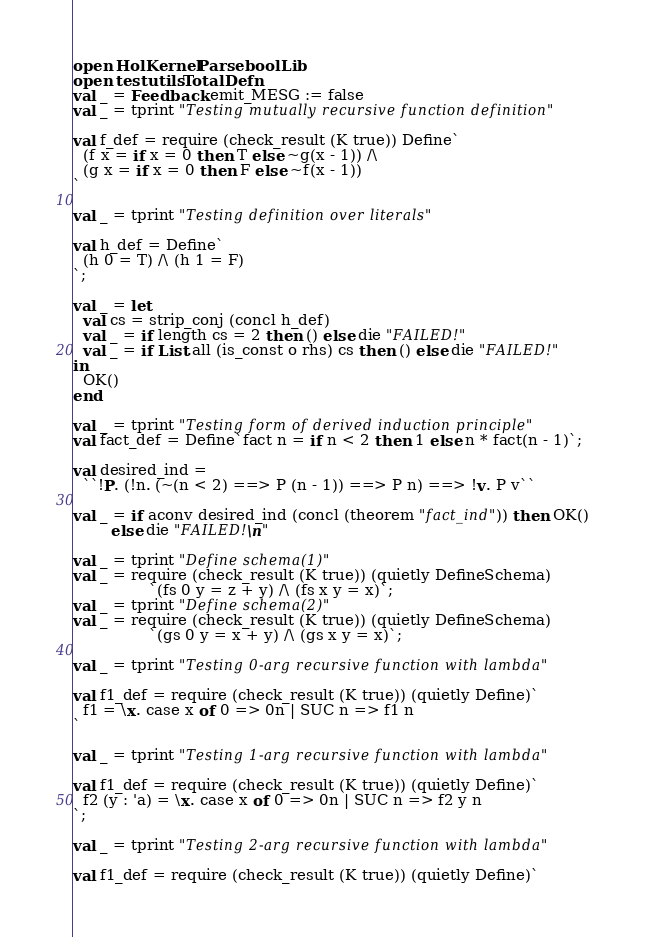Convert code to text. <code><loc_0><loc_0><loc_500><loc_500><_SML_>open HolKernel Parse boolLib
open testutils TotalDefn
val _ = Feedback.emit_MESG := false
val _ = tprint "Testing mutually recursive function definition"

val f_def = require (check_result (K true)) Define`
  (f x = if x = 0 then T else ~g(x - 1)) /\
  (g x = if x = 0 then F else ~f(x - 1))
`

val _ = tprint "Testing definition over literals"

val h_def = Define`
  (h 0 = T) /\ (h 1 = F)
`;

val _ = let
  val cs = strip_conj (concl h_def)
  val _ = if length cs = 2 then () else die "FAILED!"
  val _ = if List.all (is_const o rhs) cs then () else die "FAILED!"
in
  OK()
end

val _ = tprint "Testing form of derived induction principle"
val fact_def = Define`fact n = if n < 2 then 1 else n * fact(n - 1)`;

val desired_ind =
  ``!P. (!n. (~(n < 2) ==> P (n - 1)) ==> P n) ==> !v. P v``

val _ = if aconv desired_ind (concl (theorem "fact_ind")) then OK()
        else die "FAILED!\n"

val _ = tprint "Define schema(1)"
val _ = require (check_result (K true)) (quietly DefineSchema)
                `(fs 0 y = z + y) /\ (fs x y = x)`;
val _ = tprint "Define schema(2)"
val _ = require (check_result (K true)) (quietly DefineSchema)
                `(gs 0 y = x + y) /\ (gs x y = x)`;

val _ = tprint "Testing 0-arg recursive function with lambda"

val f1_def = require (check_result (K true)) (quietly Define)`
  f1 = \x. case x of 0 => 0n | SUC n => f1 n
`

val _ = tprint "Testing 1-arg recursive function with lambda"

val f1_def = require (check_result (K true)) (quietly Define)`
  f2 (y : 'a) = \x. case x of 0 => 0n | SUC n => f2 y n
`;

val _ = tprint "Testing 2-arg recursive function with lambda"

val f1_def = require (check_result (K true)) (quietly Define)`</code> 